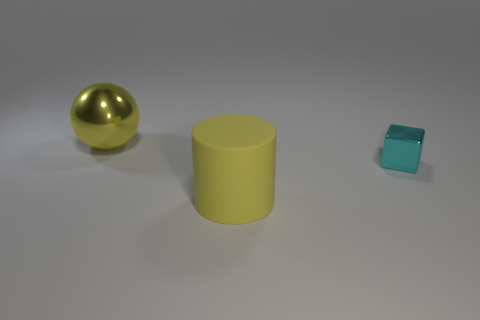Add 1 small green matte cylinders. How many objects exist? 4 Subtract all cubes. How many objects are left? 2 Add 3 yellow rubber objects. How many yellow rubber objects exist? 4 Subtract 0 gray balls. How many objects are left? 3 Subtract all matte cylinders. Subtract all large cyan matte blocks. How many objects are left? 2 Add 2 large yellow matte objects. How many large yellow matte objects are left? 3 